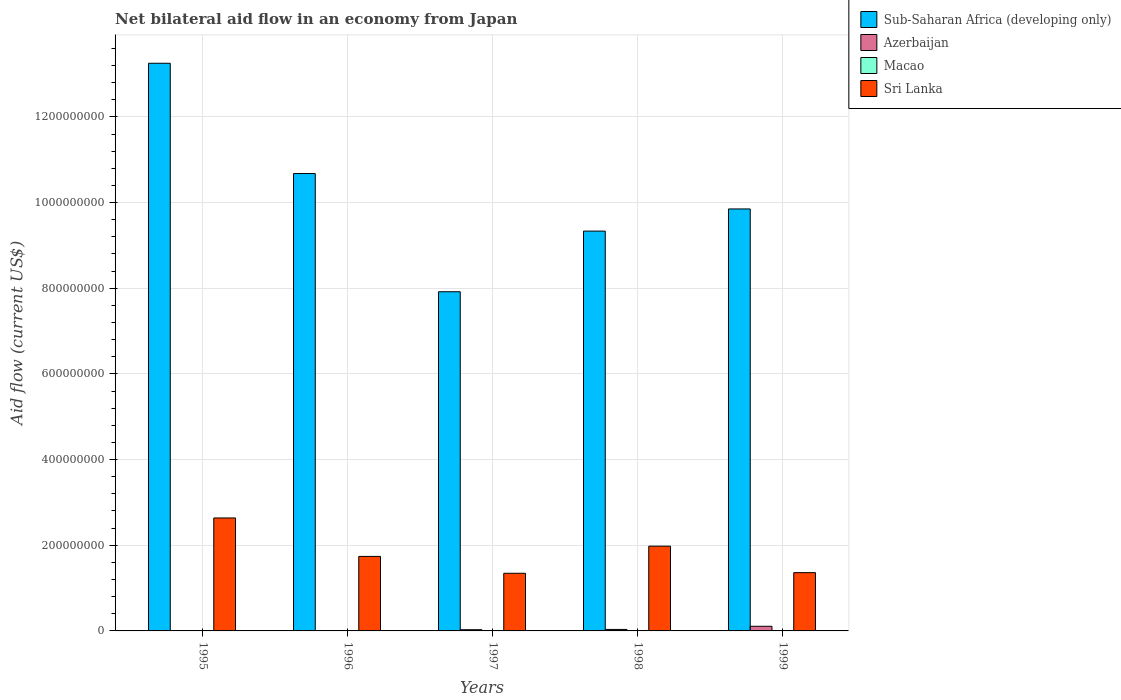How many different coloured bars are there?
Offer a terse response. 4. How many groups of bars are there?
Provide a succinct answer. 5. Are the number of bars per tick equal to the number of legend labels?
Offer a terse response. Yes. How many bars are there on the 2nd tick from the right?
Offer a very short reply. 4. What is the label of the 2nd group of bars from the left?
Offer a very short reply. 1996. What is the net bilateral aid flow in Macao in 1996?
Your response must be concise. 1.30e+05. Across all years, what is the maximum net bilateral aid flow in Azerbaijan?
Offer a very short reply. 1.08e+07. Across all years, what is the minimum net bilateral aid flow in Sub-Saharan Africa (developing only)?
Make the answer very short. 7.92e+08. What is the total net bilateral aid flow in Sub-Saharan Africa (developing only) in the graph?
Give a very brief answer. 5.10e+09. What is the difference between the net bilateral aid flow in Sub-Saharan Africa (developing only) in 1995 and that in 1997?
Provide a succinct answer. 5.33e+08. What is the difference between the net bilateral aid flow in Macao in 1998 and the net bilateral aid flow in Sub-Saharan Africa (developing only) in 1996?
Keep it short and to the point. -1.07e+09. What is the average net bilateral aid flow in Macao per year?
Give a very brief answer. 1.52e+05. In the year 1996, what is the difference between the net bilateral aid flow in Sri Lanka and net bilateral aid flow in Sub-Saharan Africa (developing only)?
Keep it short and to the point. -8.94e+08. In how many years, is the net bilateral aid flow in Macao greater than 1200000000 US$?
Ensure brevity in your answer.  0. What is the ratio of the net bilateral aid flow in Macao in 1996 to that in 1997?
Provide a short and direct response. 0.81. Is the net bilateral aid flow in Azerbaijan in 1995 less than that in 1999?
Your answer should be very brief. Yes. What is the difference between the highest and the second highest net bilateral aid flow in Azerbaijan?
Provide a short and direct response. 7.36e+06. What is the difference between the highest and the lowest net bilateral aid flow in Sub-Saharan Africa (developing only)?
Your answer should be very brief. 5.33e+08. In how many years, is the net bilateral aid flow in Sri Lanka greater than the average net bilateral aid flow in Sri Lanka taken over all years?
Offer a terse response. 2. What does the 2nd bar from the left in 1998 represents?
Your response must be concise. Azerbaijan. What does the 3rd bar from the right in 1995 represents?
Provide a short and direct response. Azerbaijan. Is it the case that in every year, the sum of the net bilateral aid flow in Azerbaijan and net bilateral aid flow in Sub-Saharan Africa (developing only) is greater than the net bilateral aid flow in Sri Lanka?
Your response must be concise. Yes. How many years are there in the graph?
Keep it short and to the point. 5. What is the difference between two consecutive major ticks on the Y-axis?
Make the answer very short. 2.00e+08. Does the graph contain any zero values?
Give a very brief answer. No. Does the graph contain grids?
Ensure brevity in your answer.  Yes. How many legend labels are there?
Ensure brevity in your answer.  4. How are the legend labels stacked?
Keep it short and to the point. Vertical. What is the title of the graph?
Provide a short and direct response. Net bilateral aid flow in an economy from Japan. Does "Thailand" appear as one of the legend labels in the graph?
Give a very brief answer. No. What is the label or title of the X-axis?
Keep it short and to the point. Years. What is the label or title of the Y-axis?
Ensure brevity in your answer.  Aid flow (current US$). What is the Aid flow (current US$) in Sub-Saharan Africa (developing only) in 1995?
Make the answer very short. 1.33e+09. What is the Aid flow (current US$) of Azerbaijan in 1995?
Your response must be concise. 6.00e+04. What is the Aid flow (current US$) in Sri Lanka in 1995?
Make the answer very short. 2.64e+08. What is the Aid flow (current US$) in Sub-Saharan Africa (developing only) in 1996?
Your answer should be very brief. 1.07e+09. What is the Aid flow (current US$) of Azerbaijan in 1996?
Your response must be concise. 3.00e+05. What is the Aid flow (current US$) in Sri Lanka in 1996?
Offer a terse response. 1.74e+08. What is the Aid flow (current US$) in Sub-Saharan Africa (developing only) in 1997?
Your answer should be compact. 7.92e+08. What is the Aid flow (current US$) of Azerbaijan in 1997?
Offer a very short reply. 2.84e+06. What is the Aid flow (current US$) of Macao in 1997?
Provide a succinct answer. 1.60e+05. What is the Aid flow (current US$) in Sri Lanka in 1997?
Give a very brief answer. 1.35e+08. What is the Aid flow (current US$) of Sub-Saharan Africa (developing only) in 1998?
Your answer should be very brief. 9.33e+08. What is the Aid flow (current US$) in Azerbaijan in 1998?
Provide a short and direct response. 3.47e+06. What is the Aid flow (current US$) in Macao in 1998?
Provide a short and direct response. 1.30e+05. What is the Aid flow (current US$) in Sri Lanka in 1998?
Ensure brevity in your answer.  1.98e+08. What is the Aid flow (current US$) in Sub-Saharan Africa (developing only) in 1999?
Make the answer very short. 9.85e+08. What is the Aid flow (current US$) of Azerbaijan in 1999?
Provide a succinct answer. 1.08e+07. What is the Aid flow (current US$) in Macao in 1999?
Provide a succinct answer. 2.10e+05. What is the Aid flow (current US$) of Sri Lanka in 1999?
Provide a short and direct response. 1.36e+08. Across all years, what is the maximum Aid flow (current US$) in Sub-Saharan Africa (developing only)?
Give a very brief answer. 1.33e+09. Across all years, what is the maximum Aid flow (current US$) in Azerbaijan?
Provide a succinct answer. 1.08e+07. Across all years, what is the maximum Aid flow (current US$) of Macao?
Keep it short and to the point. 2.10e+05. Across all years, what is the maximum Aid flow (current US$) in Sri Lanka?
Your response must be concise. 2.64e+08. Across all years, what is the minimum Aid flow (current US$) in Sub-Saharan Africa (developing only)?
Offer a very short reply. 7.92e+08. Across all years, what is the minimum Aid flow (current US$) of Azerbaijan?
Your answer should be compact. 6.00e+04. Across all years, what is the minimum Aid flow (current US$) in Macao?
Offer a terse response. 1.30e+05. Across all years, what is the minimum Aid flow (current US$) of Sri Lanka?
Make the answer very short. 1.35e+08. What is the total Aid flow (current US$) of Sub-Saharan Africa (developing only) in the graph?
Keep it short and to the point. 5.10e+09. What is the total Aid flow (current US$) in Azerbaijan in the graph?
Keep it short and to the point. 1.75e+07. What is the total Aid flow (current US$) in Macao in the graph?
Your answer should be compact. 7.60e+05. What is the total Aid flow (current US$) of Sri Lanka in the graph?
Give a very brief answer. 9.06e+08. What is the difference between the Aid flow (current US$) in Sub-Saharan Africa (developing only) in 1995 and that in 1996?
Provide a short and direct response. 2.57e+08. What is the difference between the Aid flow (current US$) of Sri Lanka in 1995 and that in 1996?
Provide a succinct answer. 8.98e+07. What is the difference between the Aid flow (current US$) in Sub-Saharan Africa (developing only) in 1995 and that in 1997?
Provide a short and direct response. 5.33e+08. What is the difference between the Aid flow (current US$) in Azerbaijan in 1995 and that in 1997?
Provide a succinct answer. -2.78e+06. What is the difference between the Aid flow (current US$) in Sri Lanka in 1995 and that in 1997?
Provide a succinct answer. 1.29e+08. What is the difference between the Aid flow (current US$) in Sub-Saharan Africa (developing only) in 1995 and that in 1998?
Keep it short and to the point. 3.92e+08. What is the difference between the Aid flow (current US$) in Azerbaijan in 1995 and that in 1998?
Keep it short and to the point. -3.41e+06. What is the difference between the Aid flow (current US$) in Sri Lanka in 1995 and that in 1998?
Your response must be concise. 6.58e+07. What is the difference between the Aid flow (current US$) in Sub-Saharan Africa (developing only) in 1995 and that in 1999?
Make the answer very short. 3.40e+08. What is the difference between the Aid flow (current US$) in Azerbaijan in 1995 and that in 1999?
Provide a succinct answer. -1.08e+07. What is the difference between the Aid flow (current US$) of Macao in 1995 and that in 1999?
Offer a very short reply. -8.00e+04. What is the difference between the Aid flow (current US$) in Sri Lanka in 1995 and that in 1999?
Make the answer very short. 1.28e+08. What is the difference between the Aid flow (current US$) in Sub-Saharan Africa (developing only) in 1996 and that in 1997?
Offer a very short reply. 2.76e+08. What is the difference between the Aid flow (current US$) of Azerbaijan in 1996 and that in 1997?
Your response must be concise. -2.54e+06. What is the difference between the Aid flow (current US$) in Sri Lanka in 1996 and that in 1997?
Ensure brevity in your answer.  3.94e+07. What is the difference between the Aid flow (current US$) of Sub-Saharan Africa (developing only) in 1996 and that in 1998?
Offer a very short reply. 1.34e+08. What is the difference between the Aid flow (current US$) of Azerbaijan in 1996 and that in 1998?
Keep it short and to the point. -3.17e+06. What is the difference between the Aid flow (current US$) of Sri Lanka in 1996 and that in 1998?
Provide a short and direct response. -2.39e+07. What is the difference between the Aid flow (current US$) in Sub-Saharan Africa (developing only) in 1996 and that in 1999?
Provide a short and direct response. 8.26e+07. What is the difference between the Aid flow (current US$) of Azerbaijan in 1996 and that in 1999?
Provide a short and direct response. -1.05e+07. What is the difference between the Aid flow (current US$) of Macao in 1996 and that in 1999?
Offer a very short reply. -8.00e+04. What is the difference between the Aid flow (current US$) of Sri Lanka in 1996 and that in 1999?
Keep it short and to the point. 3.79e+07. What is the difference between the Aid flow (current US$) in Sub-Saharan Africa (developing only) in 1997 and that in 1998?
Your answer should be very brief. -1.42e+08. What is the difference between the Aid flow (current US$) in Azerbaijan in 1997 and that in 1998?
Your response must be concise. -6.30e+05. What is the difference between the Aid flow (current US$) of Sri Lanka in 1997 and that in 1998?
Give a very brief answer. -6.33e+07. What is the difference between the Aid flow (current US$) in Sub-Saharan Africa (developing only) in 1997 and that in 1999?
Your answer should be very brief. -1.93e+08. What is the difference between the Aid flow (current US$) in Azerbaijan in 1997 and that in 1999?
Ensure brevity in your answer.  -7.99e+06. What is the difference between the Aid flow (current US$) in Sri Lanka in 1997 and that in 1999?
Keep it short and to the point. -1.47e+06. What is the difference between the Aid flow (current US$) of Sub-Saharan Africa (developing only) in 1998 and that in 1999?
Your response must be concise. -5.17e+07. What is the difference between the Aid flow (current US$) of Azerbaijan in 1998 and that in 1999?
Your answer should be very brief. -7.36e+06. What is the difference between the Aid flow (current US$) of Sri Lanka in 1998 and that in 1999?
Ensure brevity in your answer.  6.18e+07. What is the difference between the Aid flow (current US$) of Sub-Saharan Africa (developing only) in 1995 and the Aid flow (current US$) of Azerbaijan in 1996?
Your response must be concise. 1.32e+09. What is the difference between the Aid flow (current US$) in Sub-Saharan Africa (developing only) in 1995 and the Aid flow (current US$) in Macao in 1996?
Offer a very short reply. 1.33e+09. What is the difference between the Aid flow (current US$) of Sub-Saharan Africa (developing only) in 1995 and the Aid flow (current US$) of Sri Lanka in 1996?
Your answer should be compact. 1.15e+09. What is the difference between the Aid flow (current US$) of Azerbaijan in 1995 and the Aid flow (current US$) of Sri Lanka in 1996?
Offer a very short reply. -1.74e+08. What is the difference between the Aid flow (current US$) of Macao in 1995 and the Aid flow (current US$) of Sri Lanka in 1996?
Offer a terse response. -1.74e+08. What is the difference between the Aid flow (current US$) in Sub-Saharan Africa (developing only) in 1995 and the Aid flow (current US$) in Azerbaijan in 1997?
Your answer should be compact. 1.32e+09. What is the difference between the Aid flow (current US$) of Sub-Saharan Africa (developing only) in 1995 and the Aid flow (current US$) of Macao in 1997?
Offer a terse response. 1.33e+09. What is the difference between the Aid flow (current US$) of Sub-Saharan Africa (developing only) in 1995 and the Aid flow (current US$) of Sri Lanka in 1997?
Give a very brief answer. 1.19e+09. What is the difference between the Aid flow (current US$) in Azerbaijan in 1995 and the Aid flow (current US$) in Macao in 1997?
Provide a short and direct response. -1.00e+05. What is the difference between the Aid flow (current US$) of Azerbaijan in 1995 and the Aid flow (current US$) of Sri Lanka in 1997?
Offer a very short reply. -1.34e+08. What is the difference between the Aid flow (current US$) of Macao in 1995 and the Aid flow (current US$) of Sri Lanka in 1997?
Provide a succinct answer. -1.34e+08. What is the difference between the Aid flow (current US$) of Sub-Saharan Africa (developing only) in 1995 and the Aid flow (current US$) of Azerbaijan in 1998?
Provide a short and direct response. 1.32e+09. What is the difference between the Aid flow (current US$) in Sub-Saharan Africa (developing only) in 1995 and the Aid flow (current US$) in Macao in 1998?
Give a very brief answer. 1.33e+09. What is the difference between the Aid flow (current US$) in Sub-Saharan Africa (developing only) in 1995 and the Aid flow (current US$) in Sri Lanka in 1998?
Give a very brief answer. 1.13e+09. What is the difference between the Aid flow (current US$) in Azerbaijan in 1995 and the Aid flow (current US$) in Macao in 1998?
Offer a terse response. -7.00e+04. What is the difference between the Aid flow (current US$) in Azerbaijan in 1995 and the Aid flow (current US$) in Sri Lanka in 1998?
Give a very brief answer. -1.98e+08. What is the difference between the Aid flow (current US$) of Macao in 1995 and the Aid flow (current US$) of Sri Lanka in 1998?
Keep it short and to the point. -1.98e+08. What is the difference between the Aid flow (current US$) of Sub-Saharan Africa (developing only) in 1995 and the Aid flow (current US$) of Azerbaijan in 1999?
Provide a succinct answer. 1.31e+09. What is the difference between the Aid flow (current US$) in Sub-Saharan Africa (developing only) in 1995 and the Aid flow (current US$) in Macao in 1999?
Your answer should be compact. 1.32e+09. What is the difference between the Aid flow (current US$) of Sub-Saharan Africa (developing only) in 1995 and the Aid flow (current US$) of Sri Lanka in 1999?
Give a very brief answer. 1.19e+09. What is the difference between the Aid flow (current US$) of Azerbaijan in 1995 and the Aid flow (current US$) of Macao in 1999?
Keep it short and to the point. -1.50e+05. What is the difference between the Aid flow (current US$) in Azerbaijan in 1995 and the Aid flow (current US$) in Sri Lanka in 1999?
Your answer should be very brief. -1.36e+08. What is the difference between the Aid flow (current US$) in Macao in 1995 and the Aid flow (current US$) in Sri Lanka in 1999?
Your answer should be very brief. -1.36e+08. What is the difference between the Aid flow (current US$) in Sub-Saharan Africa (developing only) in 1996 and the Aid flow (current US$) in Azerbaijan in 1997?
Your answer should be very brief. 1.06e+09. What is the difference between the Aid flow (current US$) in Sub-Saharan Africa (developing only) in 1996 and the Aid flow (current US$) in Macao in 1997?
Ensure brevity in your answer.  1.07e+09. What is the difference between the Aid flow (current US$) in Sub-Saharan Africa (developing only) in 1996 and the Aid flow (current US$) in Sri Lanka in 1997?
Give a very brief answer. 9.33e+08. What is the difference between the Aid flow (current US$) in Azerbaijan in 1996 and the Aid flow (current US$) in Macao in 1997?
Your answer should be compact. 1.40e+05. What is the difference between the Aid flow (current US$) in Azerbaijan in 1996 and the Aid flow (current US$) in Sri Lanka in 1997?
Your response must be concise. -1.34e+08. What is the difference between the Aid flow (current US$) of Macao in 1996 and the Aid flow (current US$) of Sri Lanka in 1997?
Ensure brevity in your answer.  -1.34e+08. What is the difference between the Aid flow (current US$) of Sub-Saharan Africa (developing only) in 1996 and the Aid flow (current US$) of Azerbaijan in 1998?
Your response must be concise. 1.06e+09. What is the difference between the Aid flow (current US$) of Sub-Saharan Africa (developing only) in 1996 and the Aid flow (current US$) of Macao in 1998?
Your response must be concise. 1.07e+09. What is the difference between the Aid flow (current US$) of Sub-Saharan Africa (developing only) in 1996 and the Aid flow (current US$) of Sri Lanka in 1998?
Offer a terse response. 8.70e+08. What is the difference between the Aid flow (current US$) in Azerbaijan in 1996 and the Aid flow (current US$) in Sri Lanka in 1998?
Offer a very short reply. -1.98e+08. What is the difference between the Aid flow (current US$) in Macao in 1996 and the Aid flow (current US$) in Sri Lanka in 1998?
Offer a very short reply. -1.98e+08. What is the difference between the Aid flow (current US$) in Sub-Saharan Africa (developing only) in 1996 and the Aid flow (current US$) in Azerbaijan in 1999?
Keep it short and to the point. 1.06e+09. What is the difference between the Aid flow (current US$) in Sub-Saharan Africa (developing only) in 1996 and the Aid flow (current US$) in Macao in 1999?
Make the answer very short. 1.07e+09. What is the difference between the Aid flow (current US$) in Sub-Saharan Africa (developing only) in 1996 and the Aid flow (current US$) in Sri Lanka in 1999?
Make the answer very short. 9.32e+08. What is the difference between the Aid flow (current US$) of Azerbaijan in 1996 and the Aid flow (current US$) of Macao in 1999?
Your answer should be compact. 9.00e+04. What is the difference between the Aid flow (current US$) in Azerbaijan in 1996 and the Aid flow (current US$) in Sri Lanka in 1999?
Offer a terse response. -1.36e+08. What is the difference between the Aid flow (current US$) of Macao in 1996 and the Aid flow (current US$) of Sri Lanka in 1999?
Your answer should be very brief. -1.36e+08. What is the difference between the Aid flow (current US$) in Sub-Saharan Africa (developing only) in 1997 and the Aid flow (current US$) in Azerbaijan in 1998?
Offer a terse response. 7.88e+08. What is the difference between the Aid flow (current US$) of Sub-Saharan Africa (developing only) in 1997 and the Aid flow (current US$) of Macao in 1998?
Give a very brief answer. 7.92e+08. What is the difference between the Aid flow (current US$) in Sub-Saharan Africa (developing only) in 1997 and the Aid flow (current US$) in Sri Lanka in 1998?
Provide a succinct answer. 5.94e+08. What is the difference between the Aid flow (current US$) in Azerbaijan in 1997 and the Aid flow (current US$) in Macao in 1998?
Your answer should be very brief. 2.71e+06. What is the difference between the Aid flow (current US$) of Azerbaijan in 1997 and the Aid flow (current US$) of Sri Lanka in 1998?
Provide a succinct answer. -1.95e+08. What is the difference between the Aid flow (current US$) of Macao in 1997 and the Aid flow (current US$) of Sri Lanka in 1998?
Your answer should be compact. -1.98e+08. What is the difference between the Aid flow (current US$) in Sub-Saharan Africa (developing only) in 1997 and the Aid flow (current US$) in Azerbaijan in 1999?
Provide a short and direct response. 7.81e+08. What is the difference between the Aid flow (current US$) of Sub-Saharan Africa (developing only) in 1997 and the Aid flow (current US$) of Macao in 1999?
Your answer should be compact. 7.92e+08. What is the difference between the Aid flow (current US$) of Sub-Saharan Africa (developing only) in 1997 and the Aid flow (current US$) of Sri Lanka in 1999?
Give a very brief answer. 6.56e+08. What is the difference between the Aid flow (current US$) of Azerbaijan in 1997 and the Aid flow (current US$) of Macao in 1999?
Your answer should be very brief. 2.63e+06. What is the difference between the Aid flow (current US$) of Azerbaijan in 1997 and the Aid flow (current US$) of Sri Lanka in 1999?
Give a very brief answer. -1.33e+08. What is the difference between the Aid flow (current US$) of Macao in 1997 and the Aid flow (current US$) of Sri Lanka in 1999?
Ensure brevity in your answer.  -1.36e+08. What is the difference between the Aid flow (current US$) of Sub-Saharan Africa (developing only) in 1998 and the Aid flow (current US$) of Azerbaijan in 1999?
Keep it short and to the point. 9.23e+08. What is the difference between the Aid flow (current US$) of Sub-Saharan Africa (developing only) in 1998 and the Aid flow (current US$) of Macao in 1999?
Keep it short and to the point. 9.33e+08. What is the difference between the Aid flow (current US$) in Sub-Saharan Africa (developing only) in 1998 and the Aid flow (current US$) in Sri Lanka in 1999?
Your answer should be very brief. 7.97e+08. What is the difference between the Aid flow (current US$) of Azerbaijan in 1998 and the Aid flow (current US$) of Macao in 1999?
Provide a short and direct response. 3.26e+06. What is the difference between the Aid flow (current US$) in Azerbaijan in 1998 and the Aid flow (current US$) in Sri Lanka in 1999?
Your answer should be very brief. -1.33e+08. What is the difference between the Aid flow (current US$) of Macao in 1998 and the Aid flow (current US$) of Sri Lanka in 1999?
Your response must be concise. -1.36e+08. What is the average Aid flow (current US$) in Sub-Saharan Africa (developing only) per year?
Ensure brevity in your answer.  1.02e+09. What is the average Aid flow (current US$) in Azerbaijan per year?
Offer a terse response. 3.50e+06. What is the average Aid flow (current US$) in Macao per year?
Your answer should be very brief. 1.52e+05. What is the average Aid flow (current US$) of Sri Lanka per year?
Ensure brevity in your answer.  1.81e+08. In the year 1995, what is the difference between the Aid flow (current US$) of Sub-Saharan Africa (developing only) and Aid flow (current US$) of Azerbaijan?
Make the answer very short. 1.33e+09. In the year 1995, what is the difference between the Aid flow (current US$) of Sub-Saharan Africa (developing only) and Aid flow (current US$) of Macao?
Provide a succinct answer. 1.33e+09. In the year 1995, what is the difference between the Aid flow (current US$) of Sub-Saharan Africa (developing only) and Aid flow (current US$) of Sri Lanka?
Ensure brevity in your answer.  1.06e+09. In the year 1995, what is the difference between the Aid flow (current US$) of Azerbaijan and Aid flow (current US$) of Macao?
Ensure brevity in your answer.  -7.00e+04. In the year 1995, what is the difference between the Aid flow (current US$) in Azerbaijan and Aid flow (current US$) in Sri Lanka?
Provide a short and direct response. -2.64e+08. In the year 1995, what is the difference between the Aid flow (current US$) in Macao and Aid flow (current US$) in Sri Lanka?
Keep it short and to the point. -2.64e+08. In the year 1996, what is the difference between the Aid flow (current US$) of Sub-Saharan Africa (developing only) and Aid flow (current US$) of Azerbaijan?
Offer a terse response. 1.07e+09. In the year 1996, what is the difference between the Aid flow (current US$) of Sub-Saharan Africa (developing only) and Aid flow (current US$) of Macao?
Offer a terse response. 1.07e+09. In the year 1996, what is the difference between the Aid flow (current US$) of Sub-Saharan Africa (developing only) and Aid flow (current US$) of Sri Lanka?
Offer a terse response. 8.94e+08. In the year 1996, what is the difference between the Aid flow (current US$) of Azerbaijan and Aid flow (current US$) of Sri Lanka?
Ensure brevity in your answer.  -1.74e+08. In the year 1996, what is the difference between the Aid flow (current US$) in Macao and Aid flow (current US$) in Sri Lanka?
Provide a short and direct response. -1.74e+08. In the year 1997, what is the difference between the Aid flow (current US$) of Sub-Saharan Africa (developing only) and Aid flow (current US$) of Azerbaijan?
Give a very brief answer. 7.89e+08. In the year 1997, what is the difference between the Aid flow (current US$) in Sub-Saharan Africa (developing only) and Aid flow (current US$) in Macao?
Make the answer very short. 7.92e+08. In the year 1997, what is the difference between the Aid flow (current US$) in Sub-Saharan Africa (developing only) and Aid flow (current US$) in Sri Lanka?
Your response must be concise. 6.57e+08. In the year 1997, what is the difference between the Aid flow (current US$) in Azerbaijan and Aid flow (current US$) in Macao?
Offer a terse response. 2.68e+06. In the year 1997, what is the difference between the Aid flow (current US$) in Azerbaijan and Aid flow (current US$) in Sri Lanka?
Your answer should be compact. -1.32e+08. In the year 1997, what is the difference between the Aid flow (current US$) of Macao and Aid flow (current US$) of Sri Lanka?
Offer a terse response. -1.34e+08. In the year 1998, what is the difference between the Aid flow (current US$) in Sub-Saharan Africa (developing only) and Aid flow (current US$) in Azerbaijan?
Keep it short and to the point. 9.30e+08. In the year 1998, what is the difference between the Aid flow (current US$) in Sub-Saharan Africa (developing only) and Aid flow (current US$) in Macao?
Provide a succinct answer. 9.33e+08. In the year 1998, what is the difference between the Aid flow (current US$) in Sub-Saharan Africa (developing only) and Aid flow (current US$) in Sri Lanka?
Provide a succinct answer. 7.36e+08. In the year 1998, what is the difference between the Aid flow (current US$) in Azerbaijan and Aid flow (current US$) in Macao?
Provide a succinct answer. 3.34e+06. In the year 1998, what is the difference between the Aid flow (current US$) in Azerbaijan and Aid flow (current US$) in Sri Lanka?
Make the answer very short. -1.94e+08. In the year 1998, what is the difference between the Aid flow (current US$) in Macao and Aid flow (current US$) in Sri Lanka?
Your answer should be very brief. -1.98e+08. In the year 1999, what is the difference between the Aid flow (current US$) of Sub-Saharan Africa (developing only) and Aid flow (current US$) of Azerbaijan?
Offer a terse response. 9.74e+08. In the year 1999, what is the difference between the Aid flow (current US$) in Sub-Saharan Africa (developing only) and Aid flow (current US$) in Macao?
Your response must be concise. 9.85e+08. In the year 1999, what is the difference between the Aid flow (current US$) in Sub-Saharan Africa (developing only) and Aid flow (current US$) in Sri Lanka?
Offer a very short reply. 8.49e+08. In the year 1999, what is the difference between the Aid flow (current US$) in Azerbaijan and Aid flow (current US$) in Macao?
Ensure brevity in your answer.  1.06e+07. In the year 1999, what is the difference between the Aid flow (current US$) in Azerbaijan and Aid flow (current US$) in Sri Lanka?
Give a very brief answer. -1.25e+08. In the year 1999, what is the difference between the Aid flow (current US$) in Macao and Aid flow (current US$) in Sri Lanka?
Make the answer very short. -1.36e+08. What is the ratio of the Aid flow (current US$) of Sub-Saharan Africa (developing only) in 1995 to that in 1996?
Offer a terse response. 1.24. What is the ratio of the Aid flow (current US$) of Azerbaijan in 1995 to that in 1996?
Provide a short and direct response. 0.2. What is the ratio of the Aid flow (current US$) of Macao in 1995 to that in 1996?
Ensure brevity in your answer.  1. What is the ratio of the Aid flow (current US$) in Sri Lanka in 1995 to that in 1996?
Provide a succinct answer. 1.52. What is the ratio of the Aid flow (current US$) in Sub-Saharan Africa (developing only) in 1995 to that in 1997?
Offer a terse response. 1.67. What is the ratio of the Aid flow (current US$) in Azerbaijan in 1995 to that in 1997?
Your response must be concise. 0.02. What is the ratio of the Aid flow (current US$) of Macao in 1995 to that in 1997?
Provide a succinct answer. 0.81. What is the ratio of the Aid flow (current US$) in Sri Lanka in 1995 to that in 1997?
Ensure brevity in your answer.  1.96. What is the ratio of the Aid flow (current US$) of Sub-Saharan Africa (developing only) in 1995 to that in 1998?
Keep it short and to the point. 1.42. What is the ratio of the Aid flow (current US$) in Azerbaijan in 1995 to that in 1998?
Make the answer very short. 0.02. What is the ratio of the Aid flow (current US$) in Macao in 1995 to that in 1998?
Provide a succinct answer. 1. What is the ratio of the Aid flow (current US$) of Sri Lanka in 1995 to that in 1998?
Offer a very short reply. 1.33. What is the ratio of the Aid flow (current US$) in Sub-Saharan Africa (developing only) in 1995 to that in 1999?
Give a very brief answer. 1.35. What is the ratio of the Aid flow (current US$) of Azerbaijan in 1995 to that in 1999?
Your answer should be compact. 0.01. What is the ratio of the Aid flow (current US$) in Macao in 1995 to that in 1999?
Ensure brevity in your answer.  0.62. What is the ratio of the Aid flow (current US$) in Sri Lanka in 1995 to that in 1999?
Your response must be concise. 1.94. What is the ratio of the Aid flow (current US$) of Sub-Saharan Africa (developing only) in 1996 to that in 1997?
Keep it short and to the point. 1.35. What is the ratio of the Aid flow (current US$) of Azerbaijan in 1996 to that in 1997?
Offer a very short reply. 0.11. What is the ratio of the Aid flow (current US$) of Macao in 1996 to that in 1997?
Make the answer very short. 0.81. What is the ratio of the Aid flow (current US$) of Sri Lanka in 1996 to that in 1997?
Offer a terse response. 1.29. What is the ratio of the Aid flow (current US$) in Sub-Saharan Africa (developing only) in 1996 to that in 1998?
Make the answer very short. 1.14. What is the ratio of the Aid flow (current US$) of Azerbaijan in 1996 to that in 1998?
Provide a succinct answer. 0.09. What is the ratio of the Aid flow (current US$) in Macao in 1996 to that in 1998?
Offer a terse response. 1. What is the ratio of the Aid flow (current US$) of Sri Lanka in 1996 to that in 1998?
Give a very brief answer. 0.88. What is the ratio of the Aid flow (current US$) of Sub-Saharan Africa (developing only) in 1996 to that in 1999?
Your answer should be very brief. 1.08. What is the ratio of the Aid flow (current US$) in Azerbaijan in 1996 to that in 1999?
Your answer should be very brief. 0.03. What is the ratio of the Aid flow (current US$) of Macao in 1996 to that in 1999?
Give a very brief answer. 0.62. What is the ratio of the Aid flow (current US$) in Sri Lanka in 1996 to that in 1999?
Your answer should be compact. 1.28. What is the ratio of the Aid flow (current US$) of Sub-Saharan Africa (developing only) in 1997 to that in 1998?
Offer a terse response. 0.85. What is the ratio of the Aid flow (current US$) of Azerbaijan in 1997 to that in 1998?
Your answer should be very brief. 0.82. What is the ratio of the Aid flow (current US$) in Macao in 1997 to that in 1998?
Provide a succinct answer. 1.23. What is the ratio of the Aid flow (current US$) of Sri Lanka in 1997 to that in 1998?
Keep it short and to the point. 0.68. What is the ratio of the Aid flow (current US$) in Sub-Saharan Africa (developing only) in 1997 to that in 1999?
Provide a succinct answer. 0.8. What is the ratio of the Aid flow (current US$) of Azerbaijan in 1997 to that in 1999?
Make the answer very short. 0.26. What is the ratio of the Aid flow (current US$) in Macao in 1997 to that in 1999?
Give a very brief answer. 0.76. What is the ratio of the Aid flow (current US$) of Sub-Saharan Africa (developing only) in 1998 to that in 1999?
Make the answer very short. 0.95. What is the ratio of the Aid flow (current US$) in Azerbaijan in 1998 to that in 1999?
Offer a terse response. 0.32. What is the ratio of the Aid flow (current US$) of Macao in 1998 to that in 1999?
Your answer should be very brief. 0.62. What is the ratio of the Aid flow (current US$) of Sri Lanka in 1998 to that in 1999?
Provide a short and direct response. 1.45. What is the difference between the highest and the second highest Aid flow (current US$) in Sub-Saharan Africa (developing only)?
Give a very brief answer. 2.57e+08. What is the difference between the highest and the second highest Aid flow (current US$) of Azerbaijan?
Offer a very short reply. 7.36e+06. What is the difference between the highest and the second highest Aid flow (current US$) of Sri Lanka?
Provide a succinct answer. 6.58e+07. What is the difference between the highest and the lowest Aid flow (current US$) in Sub-Saharan Africa (developing only)?
Provide a short and direct response. 5.33e+08. What is the difference between the highest and the lowest Aid flow (current US$) in Azerbaijan?
Your answer should be very brief. 1.08e+07. What is the difference between the highest and the lowest Aid flow (current US$) of Sri Lanka?
Make the answer very short. 1.29e+08. 